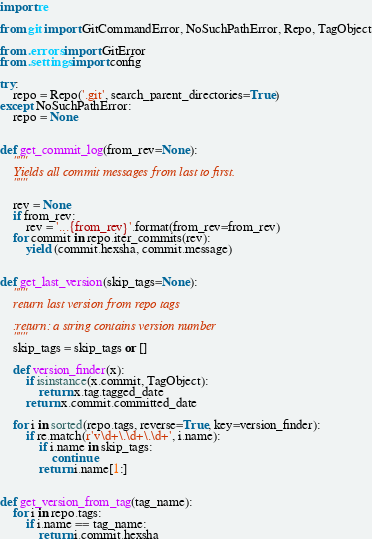<code> <loc_0><loc_0><loc_500><loc_500><_Python_>import re

from git import GitCommandError, NoSuchPathError, Repo, TagObject

from .errors import GitError
from .settings import config

try:
    repo = Repo('.git', search_parent_directories=True)
except NoSuchPathError:
    repo = None


def get_commit_log(from_rev=None):
    """
    Yields all commit messages from last to first.
    """

    rev = None
    if from_rev:
        rev = '...{from_rev}'.format(from_rev=from_rev)
    for commit in repo.iter_commits(rev):
        yield (commit.hexsha, commit.message)


def get_last_version(skip_tags=None):
    """
    return last version from repo tags

    :return: a string contains version number
    """
    skip_tags = skip_tags or []

    def version_finder(x):
        if isinstance(x.commit, TagObject):
            return x.tag.tagged_date
        return x.commit.committed_date

    for i in sorted(repo.tags, reverse=True, key=version_finder):
        if re.match(r'v\d+\.\d+\.\d+', i.name):
            if i.name in skip_tags:
                continue
            return i.name[1:]


def get_version_from_tag(tag_name):
    for i in repo.tags:
        if i.name == tag_name:
            return i.commit.hexsha

</code> 